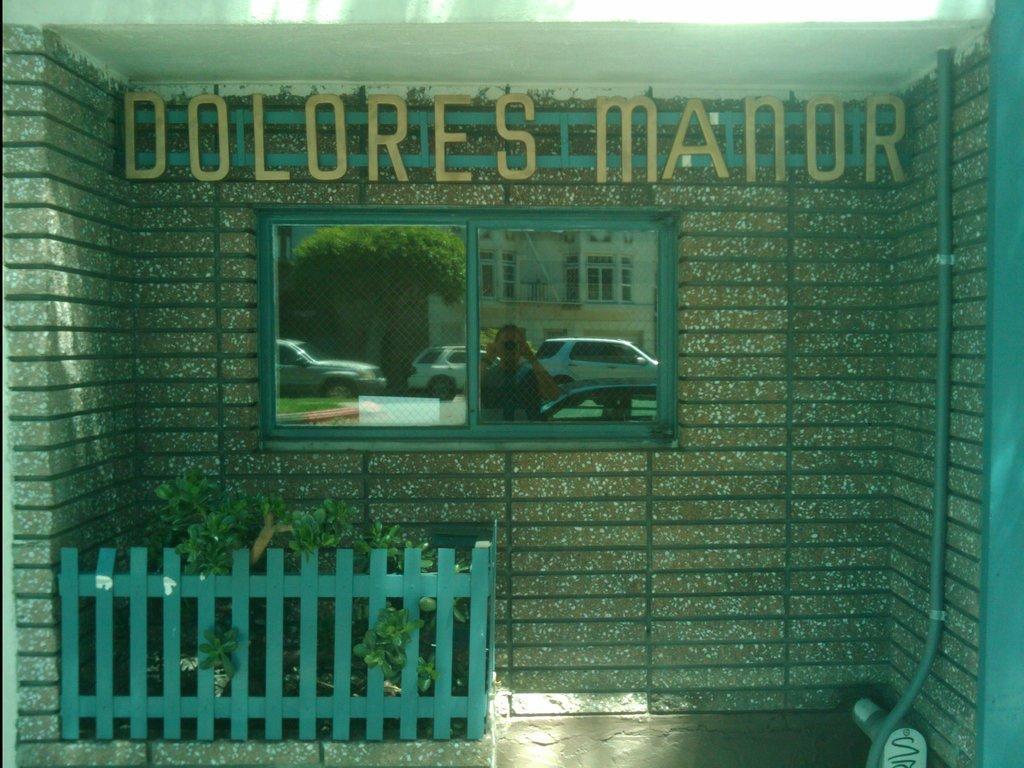How would you summarize this image in a sentence or two? In this image there is a wall having a window. On the window there is a reflection of few vehicles, buildings and trees. Before the vehicles there is a person holding the camera. Left bottom there is a fence. Behind there are few plants. Top of the image there is some text on the wall. 